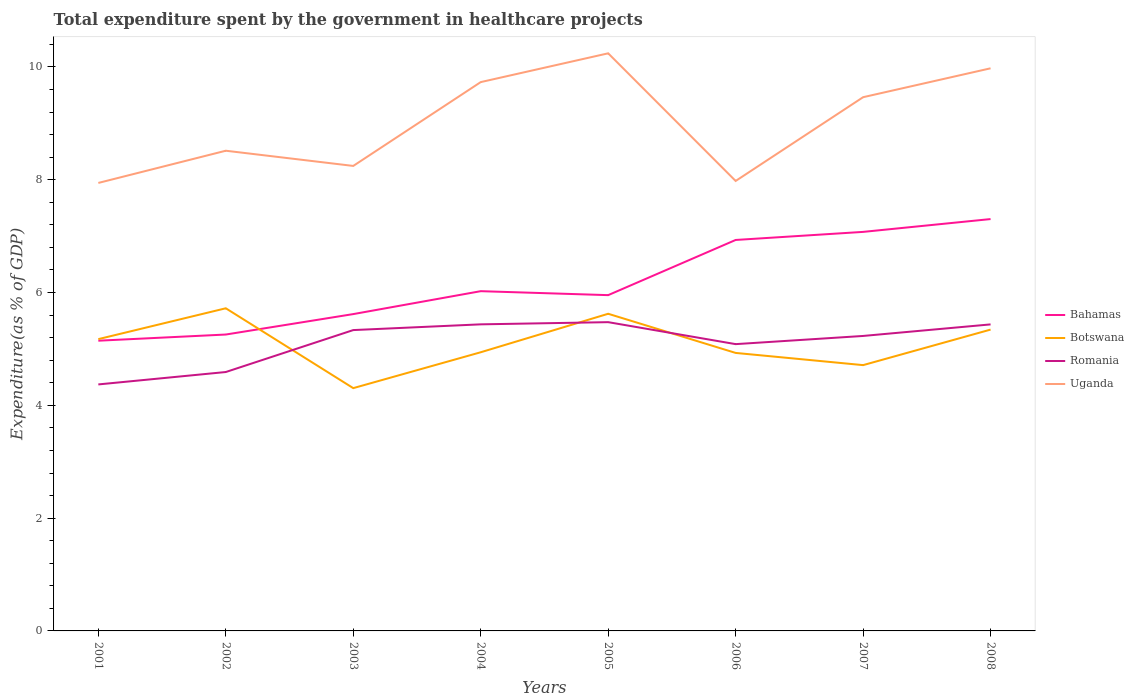Does the line corresponding to Romania intersect with the line corresponding to Botswana?
Provide a short and direct response. Yes. Is the number of lines equal to the number of legend labels?
Keep it short and to the point. Yes. Across all years, what is the maximum total expenditure spent by the government in healthcare projects in Romania?
Offer a very short reply. 4.37. What is the total total expenditure spent by the government in healthcare projects in Botswana in the graph?
Your answer should be very brief. -0.63. What is the difference between the highest and the second highest total expenditure spent by the government in healthcare projects in Uganda?
Make the answer very short. 2.3. What is the difference between two consecutive major ticks on the Y-axis?
Your response must be concise. 2. Are the values on the major ticks of Y-axis written in scientific E-notation?
Make the answer very short. No. Does the graph contain any zero values?
Your answer should be very brief. No. How many legend labels are there?
Ensure brevity in your answer.  4. How are the legend labels stacked?
Offer a terse response. Vertical. What is the title of the graph?
Your answer should be very brief. Total expenditure spent by the government in healthcare projects. Does "Nigeria" appear as one of the legend labels in the graph?
Give a very brief answer. No. What is the label or title of the Y-axis?
Your response must be concise. Expenditure(as % of GDP). What is the Expenditure(as % of GDP) in Bahamas in 2001?
Ensure brevity in your answer.  5.15. What is the Expenditure(as % of GDP) in Botswana in 2001?
Give a very brief answer. 5.17. What is the Expenditure(as % of GDP) of Romania in 2001?
Provide a short and direct response. 4.37. What is the Expenditure(as % of GDP) in Uganda in 2001?
Keep it short and to the point. 7.94. What is the Expenditure(as % of GDP) in Bahamas in 2002?
Your answer should be very brief. 5.26. What is the Expenditure(as % of GDP) in Botswana in 2002?
Make the answer very short. 5.72. What is the Expenditure(as % of GDP) of Romania in 2002?
Provide a succinct answer. 4.59. What is the Expenditure(as % of GDP) in Uganda in 2002?
Your answer should be very brief. 8.51. What is the Expenditure(as % of GDP) in Bahamas in 2003?
Make the answer very short. 5.62. What is the Expenditure(as % of GDP) in Botswana in 2003?
Your answer should be compact. 4.31. What is the Expenditure(as % of GDP) of Romania in 2003?
Provide a succinct answer. 5.33. What is the Expenditure(as % of GDP) of Uganda in 2003?
Provide a succinct answer. 8.25. What is the Expenditure(as % of GDP) in Bahamas in 2004?
Your answer should be compact. 6.02. What is the Expenditure(as % of GDP) of Botswana in 2004?
Keep it short and to the point. 4.94. What is the Expenditure(as % of GDP) in Romania in 2004?
Keep it short and to the point. 5.44. What is the Expenditure(as % of GDP) of Uganda in 2004?
Your answer should be very brief. 9.73. What is the Expenditure(as % of GDP) of Bahamas in 2005?
Keep it short and to the point. 5.95. What is the Expenditure(as % of GDP) of Botswana in 2005?
Your answer should be compact. 5.62. What is the Expenditure(as % of GDP) of Romania in 2005?
Keep it short and to the point. 5.48. What is the Expenditure(as % of GDP) in Uganda in 2005?
Keep it short and to the point. 10.24. What is the Expenditure(as % of GDP) of Bahamas in 2006?
Give a very brief answer. 6.93. What is the Expenditure(as % of GDP) of Botswana in 2006?
Keep it short and to the point. 4.93. What is the Expenditure(as % of GDP) of Romania in 2006?
Ensure brevity in your answer.  5.09. What is the Expenditure(as % of GDP) in Uganda in 2006?
Provide a succinct answer. 7.98. What is the Expenditure(as % of GDP) of Bahamas in 2007?
Make the answer very short. 7.08. What is the Expenditure(as % of GDP) in Botswana in 2007?
Your answer should be compact. 4.71. What is the Expenditure(as % of GDP) of Romania in 2007?
Ensure brevity in your answer.  5.23. What is the Expenditure(as % of GDP) of Uganda in 2007?
Ensure brevity in your answer.  9.46. What is the Expenditure(as % of GDP) in Bahamas in 2008?
Offer a terse response. 7.3. What is the Expenditure(as % of GDP) of Botswana in 2008?
Provide a short and direct response. 5.34. What is the Expenditure(as % of GDP) of Romania in 2008?
Give a very brief answer. 5.44. What is the Expenditure(as % of GDP) of Uganda in 2008?
Provide a succinct answer. 9.98. Across all years, what is the maximum Expenditure(as % of GDP) of Bahamas?
Make the answer very short. 7.3. Across all years, what is the maximum Expenditure(as % of GDP) of Botswana?
Offer a terse response. 5.72. Across all years, what is the maximum Expenditure(as % of GDP) in Romania?
Offer a terse response. 5.48. Across all years, what is the maximum Expenditure(as % of GDP) of Uganda?
Make the answer very short. 10.24. Across all years, what is the minimum Expenditure(as % of GDP) of Bahamas?
Your answer should be compact. 5.15. Across all years, what is the minimum Expenditure(as % of GDP) in Botswana?
Your answer should be very brief. 4.31. Across all years, what is the minimum Expenditure(as % of GDP) of Romania?
Provide a short and direct response. 4.37. Across all years, what is the minimum Expenditure(as % of GDP) of Uganda?
Your answer should be compact. 7.94. What is the total Expenditure(as % of GDP) of Bahamas in the graph?
Your response must be concise. 49.31. What is the total Expenditure(as % of GDP) of Botswana in the graph?
Give a very brief answer. 40.75. What is the total Expenditure(as % of GDP) of Romania in the graph?
Provide a short and direct response. 40.96. What is the total Expenditure(as % of GDP) of Uganda in the graph?
Provide a succinct answer. 72.1. What is the difference between the Expenditure(as % of GDP) of Bahamas in 2001 and that in 2002?
Your answer should be very brief. -0.11. What is the difference between the Expenditure(as % of GDP) of Botswana in 2001 and that in 2002?
Provide a short and direct response. -0.55. What is the difference between the Expenditure(as % of GDP) of Romania in 2001 and that in 2002?
Your answer should be compact. -0.22. What is the difference between the Expenditure(as % of GDP) in Uganda in 2001 and that in 2002?
Offer a very short reply. -0.57. What is the difference between the Expenditure(as % of GDP) of Bahamas in 2001 and that in 2003?
Your answer should be compact. -0.47. What is the difference between the Expenditure(as % of GDP) in Botswana in 2001 and that in 2003?
Offer a very short reply. 0.87. What is the difference between the Expenditure(as % of GDP) in Romania in 2001 and that in 2003?
Give a very brief answer. -0.96. What is the difference between the Expenditure(as % of GDP) of Uganda in 2001 and that in 2003?
Provide a short and direct response. -0.3. What is the difference between the Expenditure(as % of GDP) in Bahamas in 2001 and that in 2004?
Your response must be concise. -0.88. What is the difference between the Expenditure(as % of GDP) in Botswana in 2001 and that in 2004?
Provide a short and direct response. 0.23. What is the difference between the Expenditure(as % of GDP) in Romania in 2001 and that in 2004?
Offer a very short reply. -1.07. What is the difference between the Expenditure(as % of GDP) in Uganda in 2001 and that in 2004?
Provide a succinct answer. -1.79. What is the difference between the Expenditure(as % of GDP) of Bahamas in 2001 and that in 2005?
Your response must be concise. -0.81. What is the difference between the Expenditure(as % of GDP) in Botswana in 2001 and that in 2005?
Provide a short and direct response. -0.45. What is the difference between the Expenditure(as % of GDP) in Romania in 2001 and that in 2005?
Keep it short and to the point. -1.1. What is the difference between the Expenditure(as % of GDP) in Uganda in 2001 and that in 2005?
Give a very brief answer. -2.3. What is the difference between the Expenditure(as % of GDP) in Bahamas in 2001 and that in 2006?
Provide a succinct answer. -1.79. What is the difference between the Expenditure(as % of GDP) of Botswana in 2001 and that in 2006?
Ensure brevity in your answer.  0.24. What is the difference between the Expenditure(as % of GDP) in Romania in 2001 and that in 2006?
Make the answer very short. -0.71. What is the difference between the Expenditure(as % of GDP) of Uganda in 2001 and that in 2006?
Offer a very short reply. -0.04. What is the difference between the Expenditure(as % of GDP) of Bahamas in 2001 and that in 2007?
Your answer should be very brief. -1.93. What is the difference between the Expenditure(as % of GDP) in Botswana in 2001 and that in 2007?
Offer a terse response. 0.46. What is the difference between the Expenditure(as % of GDP) in Romania in 2001 and that in 2007?
Provide a succinct answer. -0.86. What is the difference between the Expenditure(as % of GDP) in Uganda in 2001 and that in 2007?
Ensure brevity in your answer.  -1.52. What is the difference between the Expenditure(as % of GDP) of Bahamas in 2001 and that in 2008?
Offer a terse response. -2.16. What is the difference between the Expenditure(as % of GDP) in Botswana in 2001 and that in 2008?
Provide a short and direct response. -0.17. What is the difference between the Expenditure(as % of GDP) of Romania in 2001 and that in 2008?
Your response must be concise. -1.06. What is the difference between the Expenditure(as % of GDP) of Uganda in 2001 and that in 2008?
Your answer should be very brief. -2.03. What is the difference between the Expenditure(as % of GDP) of Bahamas in 2002 and that in 2003?
Give a very brief answer. -0.36. What is the difference between the Expenditure(as % of GDP) of Botswana in 2002 and that in 2003?
Your answer should be very brief. 1.42. What is the difference between the Expenditure(as % of GDP) of Romania in 2002 and that in 2003?
Keep it short and to the point. -0.74. What is the difference between the Expenditure(as % of GDP) of Uganda in 2002 and that in 2003?
Your answer should be compact. 0.27. What is the difference between the Expenditure(as % of GDP) of Bahamas in 2002 and that in 2004?
Give a very brief answer. -0.77. What is the difference between the Expenditure(as % of GDP) in Botswana in 2002 and that in 2004?
Give a very brief answer. 0.78. What is the difference between the Expenditure(as % of GDP) of Romania in 2002 and that in 2004?
Give a very brief answer. -0.85. What is the difference between the Expenditure(as % of GDP) in Uganda in 2002 and that in 2004?
Your response must be concise. -1.22. What is the difference between the Expenditure(as % of GDP) of Bahamas in 2002 and that in 2005?
Provide a succinct answer. -0.7. What is the difference between the Expenditure(as % of GDP) in Botswana in 2002 and that in 2005?
Provide a succinct answer. 0.1. What is the difference between the Expenditure(as % of GDP) of Romania in 2002 and that in 2005?
Your answer should be compact. -0.88. What is the difference between the Expenditure(as % of GDP) in Uganda in 2002 and that in 2005?
Give a very brief answer. -1.73. What is the difference between the Expenditure(as % of GDP) in Bahamas in 2002 and that in 2006?
Your answer should be compact. -1.68. What is the difference between the Expenditure(as % of GDP) of Botswana in 2002 and that in 2006?
Provide a succinct answer. 0.79. What is the difference between the Expenditure(as % of GDP) in Romania in 2002 and that in 2006?
Your answer should be very brief. -0.49. What is the difference between the Expenditure(as % of GDP) of Uganda in 2002 and that in 2006?
Provide a short and direct response. 0.54. What is the difference between the Expenditure(as % of GDP) in Bahamas in 2002 and that in 2007?
Offer a terse response. -1.82. What is the difference between the Expenditure(as % of GDP) in Botswana in 2002 and that in 2007?
Provide a short and direct response. 1.01. What is the difference between the Expenditure(as % of GDP) of Romania in 2002 and that in 2007?
Ensure brevity in your answer.  -0.64. What is the difference between the Expenditure(as % of GDP) of Uganda in 2002 and that in 2007?
Give a very brief answer. -0.95. What is the difference between the Expenditure(as % of GDP) of Bahamas in 2002 and that in 2008?
Give a very brief answer. -2.05. What is the difference between the Expenditure(as % of GDP) of Botswana in 2002 and that in 2008?
Provide a short and direct response. 0.38. What is the difference between the Expenditure(as % of GDP) of Romania in 2002 and that in 2008?
Offer a terse response. -0.84. What is the difference between the Expenditure(as % of GDP) of Uganda in 2002 and that in 2008?
Ensure brevity in your answer.  -1.46. What is the difference between the Expenditure(as % of GDP) of Bahamas in 2003 and that in 2004?
Your response must be concise. -0.41. What is the difference between the Expenditure(as % of GDP) of Botswana in 2003 and that in 2004?
Keep it short and to the point. -0.64. What is the difference between the Expenditure(as % of GDP) in Romania in 2003 and that in 2004?
Offer a very short reply. -0.1. What is the difference between the Expenditure(as % of GDP) of Uganda in 2003 and that in 2004?
Provide a succinct answer. -1.49. What is the difference between the Expenditure(as % of GDP) in Bahamas in 2003 and that in 2005?
Provide a short and direct response. -0.34. What is the difference between the Expenditure(as % of GDP) of Botswana in 2003 and that in 2005?
Offer a very short reply. -1.32. What is the difference between the Expenditure(as % of GDP) of Romania in 2003 and that in 2005?
Offer a very short reply. -0.14. What is the difference between the Expenditure(as % of GDP) of Uganda in 2003 and that in 2005?
Provide a succinct answer. -2. What is the difference between the Expenditure(as % of GDP) in Bahamas in 2003 and that in 2006?
Ensure brevity in your answer.  -1.31. What is the difference between the Expenditure(as % of GDP) of Botswana in 2003 and that in 2006?
Provide a short and direct response. -0.62. What is the difference between the Expenditure(as % of GDP) of Romania in 2003 and that in 2006?
Offer a very short reply. 0.25. What is the difference between the Expenditure(as % of GDP) in Uganda in 2003 and that in 2006?
Give a very brief answer. 0.27. What is the difference between the Expenditure(as % of GDP) in Bahamas in 2003 and that in 2007?
Your answer should be compact. -1.46. What is the difference between the Expenditure(as % of GDP) of Botswana in 2003 and that in 2007?
Keep it short and to the point. -0.41. What is the difference between the Expenditure(as % of GDP) in Romania in 2003 and that in 2007?
Provide a succinct answer. 0.1. What is the difference between the Expenditure(as % of GDP) in Uganda in 2003 and that in 2007?
Provide a succinct answer. -1.22. What is the difference between the Expenditure(as % of GDP) of Bahamas in 2003 and that in 2008?
Your answer should be compact. -1.69. What is the difference between the Expenditure(as % of GDP) of Botswana in 2003 and that in 2008?
Give a very brief answer. -1.04. What is the difference between the Expenditure(as % of GDP) of Romania in 2003 and that in 2008?
Your answer should be very brief. -0.1. What is the difference between the Expenditure(as % of GDP) of Uganda in 2003 and that in 2008?
Give a very brief answer. -1.73. What is the difference between the Expenditure(as % of GDP) of Bahamas in 2004 and that in 2005?
Provide a succinct answer. 0.07. What is the difference between the Expenditure(as % of GDP) in Botswana in 2004 and that in 2005?
Your answer should be compact. -0.68. What is the difference between the Expenditure(as % of GDP) of Romania in 2004 and that in 2005?
Offer a terse response. -0.04. What is the difference between the Expenditure(as % of GDP) in Uganda in 2004 and that in 2005?
Your answer should be compact. -0.51. What is the difference between the Expenditure(as % of GDP) of Bahamas in 2004 and that in 2006?
Offer a terse response. -0.91. What is the difference between the Expenditure(as % of GDP) in Botswana in 2004 and that in 2006?
Offer a terse response. 0.01. What is the difference between the Expenditure(as % of GDP) in Romania in 2004 and that in 2006?
Make the answer very short. 0.35. What is the difference between the Expenditure(as % of GDP) of Uganda in 2004 and that in 2006?
Ensure brevity in your answer.  1.75. What is the difference between the Expenditure(as % of GDP) of Bahamas in 2004 and that in 2007?
Your response must be concise. -1.05. What is the difference between the Expenditure(as % of GDP) in Botswana in 2004 and that in 2007?
Give a very brief answer. 0.23. What is the difference between the Expenditure(as % of GDP) of Romania in 2004 and that in 2007?
Give a very brief answer. 0.21. What is the difference between the Expenditure(as % of GDP) of Uganda in 2004 and that in 2007?
Offer a terse response. 0.27. What is the difference between the Expenditure(as % of GDP) of Bahamas in 2004 and that in 2008?
Give a very brief answer. -1.28. What is the difference between the Expenditure(as % of GDP) of Botswana in 2004 and that in 2008?
Provide a short and direct response. -0.4. What is the difference between the Expenditure(as % of GDP) of Uganda in 2004 and that in 2008?
Your answer should be compact. -0.24. What is the difference between the Expenditure(as % of GDP) of Bahamas in 2005 and that in 2006?
Your response must be concise. -0.98. What is the difference between the Expenditure(as % of GDP) of Botswana in 2005 and that in 2006?
Keep it short and to the point. 0.69. What is the difference between the Expenditure(as % of GDP) in Romania in 2005 and that in 2006?
Ensure brevity in your answer.  0.39. What is the difference between the Expenditure(as % of GDP) of Uganda in 2005 and that in 2006?
Make the answer very short. 2.26. What is the difference between the Expenditure(as % of GDP) in Bahamas in 2005 and that in 2007?
Your response must be concise. -1.12. What is the difference between the Expenditure(as % of GDP) of Botswana in 2005 and that in 2007?
Make the answer very short. 0.91. What is the difference between the Expenditure(as % of GDP) of Romania in 2005 and that in 2007?
Your answer should be compact. 0.24. What is the difference between the Expenditure(as % of GDP) of Uganda in 2005 and that in 2007?
Ensure brevity in your answer.  0.78. What is the difference between the Expenditure(as % of GDP) in Bahamas in 2005 and that in 2008?
Provide a succinct answer. -1.35. What is the difference between the Expenditure(as % of GDP) in Botswana in 2005 and that in 2008?
Provide a succinct answer. 0.28. What is the difference between the Expenditure(as % of GDP) in Romania in 2005 and that in 2008?
Give a very brief answer. 0.04. What is the difference between the Expenditure(as % of GDP) of Uganda in 2005 and that in 2008?
Your response must be concise. 0.27. What is the difference between the Expenditure(as % of GDP) of Bahamas in 2006 and that in 2007?
Offer a very short reply. -0.14. What is the difference between the Expenditure(as % of GDP) in Botswana in 2006 and that in 2007?
Your answer should be compact. 0.22. What is the difference between the Expenditure(as % of GDP) of Romania in 2006 and that in 2007?
Keep it short and to the point. -0.15. What is the difference between the Expenditure(as % of GDP) in Uganda in 2006 and that in 2007?
Your answer should be very brief. -1.49. What is the difference between the Expenditure(as % of GDP) of Bahamas in 2006 and that in 2008?
Provide a short and direct response. -0.37. What is the difference between the Expenditure(as % of GDP) in Botswana in 2006 and that in 2008?
Your answer should be compact. -0.41. What is the difference between the Expenditure(as % of GDP) of Romania in 2006 and that in 2008?
Provide a succinct answer. -0.35. What is the difference between the Expenditure(as % of GDP) in Uganda in 2006 and that in 2008?
Keep it short and to the point. -2. What is the difference between the Expenditure(as % of GDP) in Bahamas in 2007 and that in 2008?
Keep it short and to the point. -0.23. What is the difference between the Expenditure(as % of GDP) of Botswana in 2007 and that in 2008?
Ensure brevity in your answer.  -0.63. What is the difference between the Expenditure(as % of GDP) of Romania in 2007 and that in 2008?
Keep it short and to the point. -0.2. What is the difference between the Expenditure(as % of GDP) in Uganda in 2007 and that in 2008?
Offer a very short reply. -0.51. What is the difference between the Expenditure(as % of GDP) of Bahamas in 2001 and the Expenditure(as % of GDP) of Botswana in 2002?
Your response must be concise. -0.57. What is the difference between the Expenditure(as % of GDP) in Bahamas in 2001 and the Expenditure(as % of GDP) in Romania in 2002?
Your answer should be very brief. 0.56. What is the difference between the Expenditure(as % of GDP) in Bahamas in 2001 and the Expenditure(as % of GDP) in Uganda in 2002?
Keep it short and to the point. -3.37. What is the difference between the Expenditure(as % of GDP) of Botswana in 2001 and the Expenditure(as % of GDP) of Romania in 2002?
Provide a short and direct response. 0.58. What is the difference between the Expenditure(as % of GDP) of Botswana in 2001 and the Expenditure(as % of GDP) of Uganda in 2002?
Offer a terse response. -3.34. What is the difference between the Expenditure(as % of GDP) of Romania in 2001 and the Expenditure(as % of GDP) of Uganda in 2002?
Provide a short and direct response. -4.14. What is the difference between the Expenditure(as % of GDP) of Bahamas in 2001 and the Expenditure(as % of GDP) of Botswana in 2003?
Keep it short and to the point. 0.84. What is the difference between the Expenditure(as % of GDP) of Bahamas in 2001 and the Expenditure(as % of GDP) of Romania in 2003?
Provide a short and direct response. -0.19. What is the difference between the Expenditure(as % of GDP) in Bahamas in 2001 and the Expenditure(as % of GDP) in Uganda in 2003?
Keep it short and to the point. -3.1. What is the difference between the Expenditure(as % of GDP) in Botswana in 2001 and the Expenditure(as % of GDP) in Romania in 2003?
Ensure brevity in your answer.  -0.16. What is the difference between the Expenditure(as % of GDP) in Botswana in 2001 and the Expenditure(as % of GDP) in Uganda in 2003?
Your answer should be very brief. -3.07. What is the difference between the Expenditure(as % of GDP) in Romania in 2001 and the Expenditure(as % of GDP) in Uganda in 2003?
Provide a short and direct response. -3.87. What is the difference between the Expenditure(as % of GDP) in Bahamas in 2001 and the Expenditure(as % of GDP) in Botswana in 2004?
Offer a very short reply. 0.2. What is the difference between the Expenditure(as % of GDP) in Bahamas in 2001 and the Expenditure(as % of GDP) in Romania in 2004?
Ensure brevity in your answer.  -0.29. What is the difference between the Expenditure(as % of GDP) in Bahamas in 2001 and the Expenditure(as % of GDP) in Uganda in 2004?
Offer a very short reply. -4.59. What is the difference between the Expenditure(as % of GDP) in Botswana in 2001 and the Expenditure(as % of GDP) in Romania in 2004?
Offer a very short reply. -0.26. What is the difference between the Expenditure(as % of GDP) of Botswana in 2001 and the Expenditure(as % of GDP) of Uganda in 2004?
Offer a terse response. -4.56. What is the difference between the Expenditure(as % of GDP) in Romania in 2001 and the Expenditure(as % of GDP) in Uganda in 2004?
Provide a succinct answer. -5.36. What is the difference between the Expenditure(as % of GDP) in Bahamas in 2001 and the Expenditure(as % of GDP) in Botswana in 2005?
Your answer should be very brief. -0.48. What is the difference between the Expenditure(as % of GDP) in Bahamas in 2001 and the Expenditure(as % of GDP) in Romania in 2005?
Your response must be concise. -0.33. What is the difference between the Expenditure(as % of GDP) of Bahamas in 2001 and the Expenditure(as % of GDP) of Uganda in 2005?
Offer a terse response. -5.1. What is the difference between the Expenditure(as % of GDP) of Botswana in 2001 and the Expenditure(as % of GDP) of Romania in 2005?
Give a very brief answer. -0.3. What is the difference between the Expenditure(as % of GDP) in Botswana in 2001 and the Expenditure(as % of GDP) in Uganda in 2005?
Ensure brevity in your answer.  -5.07. What is the difference between the Expenditure(as % of GDP) in Romania in 2001 and the Expenditure(as % of GDP) in Uganda in 2005?
Offer a terse response. -5.87. What is the difference between the Expenditure(as % of GDP) in Bahamas in 2001 and the Expenditure(as % of GDP) in Botswana in 2006?
Offer a terse response. 0.22. What is the difference between the Expenditure(as % of GDP) in Bahamas in 2001 and the Expenditure(as % of GDP) in Romania in 2006?
Offer a terse response. 0.06. What is the difference between the Expenditure(as % of GDP) in Bahamas in 2001 and the Expenditure(as % of GDP) in Uganda in 2006?
Provide a short and direct response. -2.83. What is the difference between the Expenditure(as % of GDP) in Botswana in 2001 and the Expenditure(as % of GDP) in Romania in 2006?
Your answer should be very brief. 0.09. What is the difference between the Expenditure(as % of GDP) in Botswana in 2001 and the Expenditure(as % of GDP) in Uganda in 2006?
Offer a very short reply. -2.8. What is the difference between the Expenditure(as % of GDP) in Romania in 2001 and the Expenditure(as % of GDP) in Uganda in 2006?
Ensure brevity in your answer.  -3.61. What is the difference between the Expenditure(as % of GDP) of Bahamas in 2001 and the Expenditure(as % of GDP) of Botswana in 2007?
Ensure brevity in your answer.  0.43. What is the difference between the Expenditure(as % of GDP) of Bahamas in 2001 and the Expenditure(as % of GDP) of Romania in 2007?
Give a very brief answer. -0.08. What is the difference between the Expenditure(as % of GDP) in Bahamas in 2001 and the Expenditure(as % of GDP) in Uganda in 2007?
Your response must be concise. -4.32. What is the difference between the Expenditure(as % of GDP) in Botswana in 2001 and the Expenditure(as % of GDP) in Romania in 2007?
Offer a very short reply. -0.06. What is the difference between the Expenditure(as % of GDP) in Botswana in 2001 and the Expenditure(as % of GDP) in Uganda in 2007?
Ensure brevity in your answer.  -4.29. What is the difference between the Expenditure(as % of GDP) in Romania in 2001 and the Expenditure(as % of GDP) in Uganda in 2007?
Keep it short and to the point. -5.09. What is the difference between the Expenditure(as % of GDP) of Bahamas in 2001 and the Expenditure(as % of GDP) of Botswana in 2008?
Your response must be concise. -0.2. What is the difference between the Expenditure(as % of GDP) in Bahamas in 2001 and the Expenditure(as % of GDP) in Romania in 2008?
Offer a very short reply. -0.29. What is the difference between the Expenditure(as % of GDP) of Bahamas in 2001 and the Expenditure(as % of GDP) of Uganda in 2008?
Provide a succinct answer. -4.83. What is the difference between the Expenditure(as % of GDP) of Botswana in 2001 and the Expenditure(as % of GDP) of Romania in 2008?
Offer a terse response. -0.26. What is the difference between the Expenditure(as % of GDP) of Botswana in 2001 and the Expenditure(as % of GDP) of Uganda in 2008?
Provide a succinct answer. -4.8. What is the difference between the Expenditure(as % of GDP) in Romania in 2001 and the Expenditure(as % of GDP) in Uganda in 2008?
Your answer should be very brief. -5.61. What is the difference between the Expenditure(as % of GDP) in Bahamas in 2002 and the Expenditure(as % of GDP) in Botswana in 2003?
Offer a terse response. 0.95. What is the difference between the Expenditure(as % of GDP) of Bahamas in 2002 and the Expenditure(as % of GDP) of Romania in 2003?
Keep it short and to the point. -0.08. What is the difference between the Expenditure(as % of GDP) of Bahamas in 2002 and the Expenditure(as % of GDP) of Uganda in 2003?
Your answer should be compact. -2.99. What is the difference between the Expenditure(as % of GDP) in Botswana in 2002 and the Expenditure(as % of GDP) in Romania in 2003?
Provide a short and direct response. 0.39. What is the difference between the Expenditure(as % of GDP) of Botswana in 2002 and the Expenditure(as % of GDP) of Uganda in 2003?
Keep it short and to the point. -2.52. What is the difference between the Expenditure(as % of GDP) in Romania in 2002 and the Expenditure(as % of GDP) in Uganda in 2003?
Your response must be concise. -3.65. What is the difference between the Expenditure(as % of GDP) in Bahamas in 2002 and the Expenditure(as % of GDP) in Botswana in 2004?
Offer a terse response. 0.31. What is the difference between the Expenditure(as % of GDP) of Bahamas in 2002 and the Expenditure(as % of GDP) of Romania in 2004?
Your answer should be very brief. -0.18. What is the difference between the Expenditure(as % of GDP) of Bahamas in 2002 and the Expenditure(as % of GDP) of Uganda in 2004?
Your response must be concise. -4.48. What is the difference between the Expenditure(as % of GDP) in Botswana in 2002 and the Expenditure(as % of GDP) in Romania in 2004?
Make the answer very short. 0.28. What is the difference between the Expenditure(as % of GDP) of Botswana in 2002 and the Expenditure(as % of GDP) of Uganda in 2004?
Your answer should be very brief. -4.01. What is the difference between the Expenditure(as % of GDP) of Romania in 2002 and the Expenditure(as % of GDP) of Uganda in 2004?
Ensure brevity in your answer.  -5.14. What is the difference between the Expenditure(as % of GDP) of Bahamas in 2002 and the Expenditure(as % of GDP) of Botswana in 2005?
Your answer should be compact. -0.37. What is the difference between the Expenditure(as % of GDP) of Bahamas in 2002 and the Expenditure(as % of GDP) of Romania in 2005?
Give a very brief answer. -0.22. What is the difference between the Expenditure(as % of GDP) of Bahamas in 2002 and the Expenditure(as % of GDP) of Uganda in 2005?
Offer a very short reply. -4.99. What is the difference between the Expenditure(as % of GDP) of Botswana in 2002 and the Expenditure(as % of GDP) of Romania in 2005?
Ensure brevity in your answer.  0.25. What is the difference between the Expenditure(as % of GDP) in Botswana in 2002 and the Expenditure(as % of GDP) in Uganda in 2005?
Make the answer very short. -4.52. What is the difference between the Expenditure(as % of GDP) of Romania in 2002 and the Expenditure(as % of GDP) of Uganda in 2005?
Ensure brevity in your answer.  -5.65. What is the difference between the Expenditure(as % of GDP) in Bahamas in 2002 and the Expenditure(as % of GDP) in Botswana in 2006?
Give a very brief answer. 0.33. What is the difference between the Expenditure(as % of GDP) in Bahamas in 2002 and the Expenditure(as % of GDP) in Romania in 2006?
Offer a very short reply. 0.17. What is the difference between the Expenditure(as % of GDP) in Bahamas in 2002 and the Expenditure(as % of GDP) in Uganda in 2006?
Your answer should be compact. -2.72. What is the difference between the Expenditure(as % of GDP) in Botswana in 2002 and the Expenditure(as % of GDP) in Romania in 2006?
Provide a short and direct response. 0.64. What is the difference between the Expenditure(as % of GDP) of Botswana in 2002 and the Expenditure(as % of GDP) of Uganda in 2006?
Keep it short and to the point. -2.26. What is the difference between the Expenditure(as % of GDP) of Romania in 2002 and the Expenditure(as % of GDP) of Uganda in 2006?
Your response must be concise. -3.39. What is the difference between the Expenditure(as % of GDP) of Bahamas in 2002 and the Expenditure(as % of GDP) of Botswana in 2007?
Give a very brief answer. 0.54. What is the difference between the Expenditure(as % of GDP) of Bahamas in 2002 and the Expenditure(as % of GDP) of Romania in 2007?
Ensure brevity in your answer.  0.03. What is the difference between the Expenditure(as % of GDP) of Bahamas in 2002 and the Expenditure(as % of GDP) of Uganda in 2007?
Keep it short and to the point. -4.21. What is the difference between the Expenditure(as % of GDP) in Botswana in 2002 and the Expenditure(as % of GDP) in Romania in 2007?
Your answer should be compact. 0.49. What is the difference between the Expenditure(as % of GDP) of Botswana in 2002 and the Expenditure(as % of GDP) of Uganda in 2007?
Provide a short and direct response. -3.74. What is the difference between the Expenditure(as % of GDP) of Romania in 2002 and the Expenditure(as % of GDP) of Uganda in 2007?
Make the answer very short. -4.87. What is the difference between the Expenditure(as % of GDP) of Bahamas in 2002 and the Expenditure(as % of GDP) of Botswana in 2008?
Make the answer very short. -0.09. What is the difference between the Expenditure(as % of GDP) of Bahamas in 2002 and the Expenditure(as % of GDP) of Romania in 2008?
Your answer should be compact. -0.18. What is the difference between the Expenditure(as % of GDP) in Bahamas in 2002 and the Expenditure(as % of GDP) in Uganda in 2008?
Your response must be concise. -4.72. What is the difference between the Expenditure(as % of GDP) in Botswana in 2002 and the Expenditure(as % of GDP) in Romania in 2008?
Keep it short and to the point. 0.29. What is the difference between the Expenditure(as % of GDP) in Botswana in 2002 and the Expenditure(as % of GDP) in Uganda in 2008?
Keep it short and to the point. -4.26. What is the difference between the Expenditure(as % of GDP) of Romania in 2002 and the Expenditure(as % of GDP) of Uganda in 2008?
Provide a short and direct response. -5.39. What is the difference between the Expenditure(as % of GDP) in Bahamas in 2003 and the Expenditure(as % of GDP) in Botswana in 2004?
Your response must be concise. 0.68. What is the difference between the Expenditure(as % of GDP) in Bahamas in 2003 and the Expenditure(as % of GDP) in Romania in 2004?
Give a very brief answer. 0.18. What is the difference between the Expenditure(as % of GDP) in Bahamas in 2003 and the Expenditure(as % of GDP) in Uganda in 2004?
Make the answer very short. -4.11. What is the difference between the Expenditure(as % of GDP) of Botswana in 2003 and the Expenditure(as % of GDP) of Romania in 2004?
Ensure brevity in your answer.  -1.13. What is the difference between the Expenditure(as % of GDP) of Botswana in 2003 and the Expenditure(as % of GDP) of Uganda in 2004?
Give a very brief answer. -5.43. What is the difference between the Expenditure(as % of GDP) of Romania in 2003 and the Expenditure(as % of GDP) of Uganda in 2004?
Keep it short and to the point. -4.4. What is the difference between the Expenditure(as % of GDP) of Bahamas in 2003 and the Expenditure(as % of GDP) of Botswana in 2005?
Provide a succinct answer. -0.01. What is the difference between the Expenditure(as % of GDP) in Bahamas in 2003 and the Expenditure(as % of GDP) in Romania in 2005?
Make the answer very short. 0.14. What is the difference between the Expenditure(as % of GDP) of Bahamas in 2003 and the Expenditure(as % of GDP) of Uganda in 2005?
Your answer should be compact. -4.62. What is the difference between the Expenditure(as % of GDP) in Botswana in 2003 and the Expenditure(as % of GDP) in Romania in 2005?
Provide a short and direct response. -1.17. What is the difference between the Expenditure(as % of GDP) of Botswana in 2003 and the Expenditure(as % of GDP) of Uganda in 2005?
Keep it short and to the point. -5.94. What is the difference between the Expenditure(as % of GDP) in Romania in 2003 and the Expenditure(as % of GDP) in Uganda in 2005?
Make the answer very short. -4.91. What is the difference between the Expenditure(as % of GDP) of Bahamas in 2003 and the Expenditure(as % of GDP) of Botswana in 2006?
Offer a very short reply. 0.69. What is the difference between the Expenditure(as % of GDP) of Bahamas in 2003 and the Expenditure(as % of GDP) of Romania in 2006?
Ensure brevity in your answer.  0.53. What is the difference between the Expenditure(as % of GDP) in Bahamas in 2003 and the Expenditure(as % of GDP) in Uganda in 2006?
Your response must be concise. -2.36. What is the difference between the Expenditure(as % of GDP) of Botswana in 2003 and the Expenditure(as % of GDP) of Romania in 2006?
Your answer should be very brief. -0.78. What is the difference between the Expenditure(as % of GDP) of Botswana in 2003 and the Expenditure(as % of GDP) of Uganda in 2006?
Provide a short and direct response. -3.67. What is the difference between the Expenditure(as % of GDP) in Romania in 2003 and the Expenditure(as % of GDP) in Uganda in 2006?
Your answer should be compact. -2.64. What is the difference between the Expenditure(as % of GDP) of Bahamas in 2003 and the Expenditure(as % of GDP) of Botswana in 2007?
Offer a very short reply. 0.9. What is the difference between the Expenditure(as % of GDP) in Bahamas in 2003 and the Expenditure(as % of GDP) in Romania in 2007?
Offer a very short reply. 0.39. What is the difference between the Expenditure(as % of GDP) of Bahamas in 2003 and the Expenditure(as % of GDP) of Uganda in 2007?
Ensure brevity in your answer.  -3.85. What is the difference between the Expenditure(as % of GDP) of Botswana in 2003 and the Expenditure(as % of GDP) of Romania in 2007?
Your answer should be compact. -0.93. What is the difference between the Expenditure(as % of GDP) in Botswana in 2003 and the Expenditure(as % of GDP) in Uganda in 2007?
Make the answer very short. -5.16. What is the difference between the Expenditure(as % of GDP) in Romania in 2003 and the Expenditure(as % of GDP) in Uganda in 2007?
Offer a terse response. -4.13. What is the difference between the Expenditure(as % of GDP) in Bahamas in 2003 and the Expenditure(as % of GDP) in Botswana in 2008?
Provide a short and direct response. 0.27. What is the difference between the Expenditure(as % of GDP) of Bahamas in 2003 and the Expenditure(as % of GDP) of Romania in 2008?
Your answer should be compact. 0.18. What is the difference between the Expenditure(as % of GDP) of Bahamas in 2003 and the Expenditure(as % of GDP) of Uganda in 2008?
Provide a short and direct response. -4.36. What is the difference between the Expenditure(as % of GDP) in Botswana in 2003 and the Expenditure(as % of GDP) in Romania in 2008?
Your response must be concise. -1.13. What is the difference between the Expenditure(as % of GDP) in Botswana in 2003 and the Expenditure(as % of GDP) in Uganda in 2008?
Give a very brief answer. -5.67. What is the difference between the Expenditure(as % of GDP) in Romania in 2003 and the Expenditure(as % of GDP) in Uganda in 2008?
Give a very brief answer. -4.64. What is the difference between the Expenditure(as % of GDP) of Bahamas in 2004 and the Expenditure(as % of GDP) of Botswana in 2005?
Offer a very short reply. 0.4. What is the difference between the Expenditure(as % of GDP) of Bahamas in 2004 and the Expenditure(as % of GDP) of Romania in 2005?
Make the answer very short. 0.55. What is the difference between the Expenditure(as % of GDP) in Bahamas in 2004 and the Expenditure(as % of GDP) in Uganda in 2005?
Provide a short and direct response. -4.22. What is the difference between the Expenditure(as % of GDP) of Botswana in 2004 and the Expenditure(as % of GDP) of Romania in 2005?
Provide a short and direct response. -0.53. What is the difference between the Expenditure(as % of GDP) in Botswana in 2004 and the Expenditure(as % of GDP) in Uganda in 2005?
Ensure brevity in your answer.  -5.3. What is the difference between the Expenditure(as % of GDP) in Romania in 2004 and the Expenditure(as % of GDP) in Uganda in 2005?
Give a very brief answer. -4.81. What is the difference between the Expenditure(as % of GDP) of Bahamas in 2004 and the Expenditure(as % of GDP) of Botswana in 2006?
Provide a succinct answer. 1.09. What is the difference between the Expenditure(as % of GDP) of Bahamas in 2004 and the Expenditure(as % of GDP) of Romania in 2006?
Provide a succinct answer. 0.94. What is the difference between the Expenditure(as % of GDP) of Bahamas in 2004 and the Expenditure(as % of GDP) of Uganda in 2006?
Give a very brief answer. -1.95. What is the difference between the Expenditure(as % of GDP) of Botswana in 2004 and the Expenditure(as % of GDP) of Romania in 2006?
Your response must be concise. -0.14. What is the difference between the Expenditure(as % of GDP) of Botswana in 2004 and the Expenditure(as % of GDP) of Uganda in 2006?
Make the answer very short. -3.04. What is the difference between the Expenditure(as % of GDP) in Romania in 2004 and the Expenditure(as % of GDP) in Uganda in 2006?
Your answer should be very brief. -2.54. What is the difference between the Expenditure(as % of GDP) of Bahamas in 2004 and the Expenditure(as % of GDP) of Botswana in 2007?
Provide a succinct answer. 1.31. What is the difference between the Expenditure(as % of GDP) of Bahamas in 2004 and the Expenditure(as % of GDP) of Romania in 2007?
Ensure brevity in your answer.  0.79. What is the difference between the Expenditure(as % of GDP) of Bahamas in 2004 and the Expenditure(as % of GDP) of Uganda in 2007?
Make the answer very short. -3.44. What is the difference between the Expenditure(as % of GDP) of Botswana in 2004 and the Expenditure(as % of GDP) of Romania in 2007?
Your response must be concise. -0.29. What is the difference between the Expenditure(as % of GDP) of Botswana in 2004 and the Expenditure(as % of GDP) of Uganda in 2007?
Give a very brief answer. -4.52. What is the difference between the Expenditure(as % of GDP) in Romania in 2004 and the Expenditure(as % of GDP) in Uganda in 2007?
Offer a terse response. -4.03. What is the difference between the Expenditure(as % of GDP) of Bahamas in 2004 and the Expenditure(as % of GDP) of Botswana in 2008?
Ensure brevity in your answer.  0.68. What is the difference between the Expenditure(as % of GDP) in Bahamas in 2004 and the Expenditure(as % of GDP) in Romania in 2008?
Provide a short and direct response. 0.59. What is the difference between the Expenditure(as % of GDP) of Bahamas in 2004 and the Expenditure(as % of GDP) of Uganda in 2008?
Offer a very short reply. -3.95. What is the difference between the Expenditure(as % of GDP) of Botswana in 2004 and the Expenditure(as % of GDP) of Romania in 2008?
Your response must be concise. -0.49. What is the difference between the Expenditure(as % of GDP) of Botswana in 2004 and the Expenditure(as % of GDP) of Uganda in 2008?
Give a very brief answer. -5.04. What is the difference between the Expenditure(as % of GDP) of Romania in 2004 and the Expenditure(as % of GDP) of Uganda in 2008?
Your answer should be compact. -4.54. What is the difference between the Expenditure(as % of GDP) in Bahamas in 2005 and the Expenditure(as % of GDP) in Botswana in 2006?
Keep it short and to the point. 1.02. What is the difference between the Expenditure(as % of GDP) of Bahamas in 2005 and the Expenditure(as % of GDP) of Romania in 2006?
Offer a terse response. 0.87. What is the difference between the Expenditure(as % of GDP) in Bahamas in 2005 and the Expenditure(as % of GDP) in Uganda in 2006?
Your answer should be very brief. -2.02. What is the difference between the Expenditure(as % of GDP) of Botswana in 2005 and the Expenditure(as % of GDP) of Romania in 2006?
Your response must be concise. 0.54. What is the difference between the Expenditure(as % of GDP) in Botswana in 2005 and the Expenditure(as % of GDP) in Uganda in 2006?
Provide a short and direct response. -2.36. What is the difference between the Expenditure(as % of GDP) in Romania in 2005 and the Expenditure(as % of GDP) in Uganda in 2006?
Offer a very short reply. -2.5. What is the difference between the Expenditure(as % of GDP) in Bahamas in 2005 and the Expenditure(as % of GDP) in Botswana in 2007?
Keep it short and to the point. 1.24. What is the difference between the Expenditure(as % of GDP) of Bahamas in 2005 and the Expenditure(as % of GDP) of Romania in 2007?
Keep it short and to the point. 0.72. What is the difference between the Expenditure(as % of GDP) in Bahamas in 2005 and the Expenditure(as % of GDP) in Uganda in 2007?
Offer a very short reply. -3.51. What is the difference between the Expenditure(as % of GDP) of Botswana in 2005 and the Expenditure(as % of GDP) of Romania in 2007?
Give a very brief answer. 0.39. What is the difference between the Expenditure(as % of GDP) of Botswana in 2005 and the Expenditure(as % of GDP) of Uganda in 2007?
Offer a very short reply. -3.84. What is the difference between the Expenditure(as % of GDP) in Romania in 2005 and the Expenditure(as % of GDP) in Uganda in 2007?
Make the answer very short. -3.99. What is the difference between the Expenditure(as % of GDP) of Bahamas in 2005 and the Expenditure(as % of GDP) of Botswana in 2008?
Offer a terse response. 0.61. What is the difference between the Expenditure(as % of GDP) of Bahamas in 2005 and the Expenditure(as % of GDP) of Romania in 2008?
Make the answer very short. 0.52. What is the difference between the Expenditure(as % of GDP) in Bahamas in 2005 and the Expenditure(as % of GDP) in Uganda in 2008?
Keep it short and to the point. -4.02. What is the difference between the Expenditure(as % of GDP) of Botswana in 2005 and the Expenditure(as % of GDP) of Romania in 2008?
Offer a very short reply. 0.19. What is the difference between the Expenditure(as % of GDP) in Botswana in 2005 and the Expenditure(as % of GDP) in Uganda in 2008?
Ensure brevity in your answer.  -4.35. What is the difference between the Expenditure(as % of GDP) in Romania in 2005 and the Expenditure(as % of GDP) in Uganda in 2008?
Provide a succinct answer. -4.5. What is the difference between the Expenditure(as % of GDP) of Bahamas in 2006 and the Expenditure(as % of GDP) of Botswana in 2007?
Keep it short and to the point. 2.22. What is the difference between the Expenditure(as % of GDP) in Bahamas in 2006 and the Expenditure(as % of GDP) in Romania in 2007?
Give a very brief answer. 1.7. What is the difference between the Expenditure(as % of GDP) of Bahamas in 2006 and the Expenditure(as % of GDP) of Uganda in 2007?
Provide a short and direct response. -2.53. What is the difference between the Expenditure(as % of GDP) of Botswana in 2006 and the Expenditure(as % of GDP) of Romania in 2007?
Your answer should be very brief. -0.3. What is the difference between the Expenditure(as % of GDP) in Botswana in 2006 and the Expenditure(as % of GDP) in Uganda in 2007?
Ensure brevity in your answer.  -4.53. What is the difference between the Expenditure(as % of GDP) of Romania in 2006 and the Expenditure(as % of GDP) of Uganda in 2007?
Keep it short and to the point. -4.38. What is the difference between the Expenditure(as % of GDP) in Bahamas in 2006 and the Expenditure(as % of GDP) in Botswana in 2008?
Your response must be concise. 1.59. What is the difference between the Expenditure(as % of GDP) of Bahamas in 2006 and the Expenditure(as % of GDP) of Romania in 2008?
Your response must be concise. 1.5. What is the difference between the Expenditure(as % of GDP) in Bahamas in 2006 and the Expenditure(as % of GDP) in Uganda in 2008?
Your answer should be compact. -3.04. What is the difference between the Expenditure(as % of GDP) of Botswana in 2006 and the Expenditure(as % of GDP) of Romania in 2008?
Your response must be concise. -0.51. What is the difference between the Expenditure(as % of GDP) of Botswana in 2006 and the Expenditure(as % of GDP) of Uganda in 2008?
Your answer should be very brief. -5.05. What is the difference between the Expenditure(as % of GDP) of Romania in 2006 and the Expenditure(as % of GDP) of Uganda in 2008?
Provide a short and direct response. -4.89. What is the difference between the Expenditure(as % of GDP) of Bahamas in 2007 and the Expenditure(as % of GDP) of Botswana in 2008?
Offer a terse response. 1.73. What is the difference between the Expenditure(as % of GDP) in Bahamas in 2007 and the Expenditure(as % of GDP) in Romania in 2008?
Keep it short and to the point. 1.64. What is the difference between the Expenditure(as % of GDP) of Bahamas in 2007 and the Expenditure(as % of GDP) of Uganda in 2008?
Give a very brief answer. -2.9. What is the difference between the Expenditure(as % of GDP) in Botswana in 2007 and the Expenditure(as % of GDP) in Romania in 2008?
Provide a succinct answer. -0.72. What is the difference between the Expenditure(as % of GDP) in Botswana in 2007 and the Expenditure(as % of GDP) in Uganda in 2008?
Make the answer very short. -5.26. What is the difference between the Expenditure(as % of GDP) in Romania in 2007 and the Expenditure(as % of GDP) in Uganda in 2008?
Give a very brief answer. -4.75. What is the average Expenditure(as % of GDP) in Bahamas per year?
Provide a short and direct response. 6.16. What is the average Expenditure(as % of GDP) in Botswana per year?
Ensure brevity in your answer.  5.09. What is the average Expenditure(as % of GDP) in Romania per year?
Give a very brief answer. 5.12. What is the average Expenditure(as % of GDP) of Uganda per year?
Offer a terse response. 9.01. In the year 2001, what is the difference between the Expenditure(as % of GDP) of Bahamas and Expenditure(as % of GDP) of Botswana?
Offer a very short reply. -0.03. In the year 2001, what is the difference between the Expenditure(as % of GDP) of Bahamas and Expenditure(as % of GDP) of Romania?
Ensure brevity in your answer.  0.78. In the year 2001, what is the difference between the Expenditure(as % of GDP) in Bahamas and Expenditure(as % of GDP) in Uganda?
Your answer should be very brief. -2.8. In the year 2001, what is the difference between the Expenditure(as % of GDP) in Botswana and Expenditure(as % of GDP) in Romania?
Offer a very short reply. 0.8. In the year 2001, what is the difference between the Expenditure(as % of GDP) of Botswana and Expenditure(as % of GDP) of Uganda?
Your answer should be compact. -2.77. In the year 2001, what is the difference between the Expenditure(as % of GDP) in Romania and Expenditure(as % of GDP) in Uganda?
Keep it short and to the point. -3.57. In the year 2002, what is the difference between the Expenditure(as % of GDP) of Bahamas and Expenditure(as % of GDP) of Botswana?
Offer a very short reply. -0.47. In the year 2002, what is the difference between the Expenditure(as % of GDP) of Bahamas and Expenditure(as % of GDP) of Romania?
Your answer should be very brief. 0.66. In the year 2002, what is the difference between the Expenditure(as % of GDP) of Bahamas and Expenditure(as % of GDP) of Uganda?
Your answer should be compact. -3.26. In the year 2002, what is the difference between the Expenditure(as % of GDP) in Botswana and Expenditure(as % of GDP) in Romania?
Give a very brief answer. 1.13. In the year 2002, what is the difference between the Expenditure(as % of GDP) of Botswana and Expenditure(as % of GDP) of Uganda?
Give a very brief answer. -2.79. In the year 2002, what is the difference between the Expenditure(as % of GDP) in Romania and Expenditure(as % of GDP) in Uganda?
Your answer should be compact. -3.92. In the year 2003, what is the difference between the Expenditure(as % of GDP) of Bahamas and Expenditure(as % of GDP) of Botswana?
Make the answer very short. 1.31. In the year 2003, what is the difference between the Expenditure(as % of GDP) of Bahamas and Expenditure(as % of GDP) of Romania?
Your response must be concise. 0.28. In the year 2003, what is the difference between the Expenditure(as % of GDP) of Bahamas and Expenditure(as % of GDP) of Uganda?
Make the answer very short. -2.63. In the year 2003, what is the difference between the Expenditure(as % of GDP) of Botswana and Expenditure(as % of GDP) of Romania?
Make the answer very short. -1.03. In the year 2003, what is the difference between the Expenditure(as % of GDP) in Botswana and Expenditure(as % of GDP) in Uganda?
Provide a short and direct response. -3.94. In the year 2003, what is the difference between the Expenditure(as % of GDP) in Romania and Expenditure(as % of GDP) in Uganda?
Make the answer very short. -2.91. In the year 2004, what is the difference between the Expenditure(as % of GDP) in Bahamas and Expenditure(as % of GDP) in Botswana?
Give a very brief answer. 1.08. In the year 2004, what is the difference between the Expenditure(as % of GDP) in Bahamas and Expenditure(as % of GDP) in Romania?
Ensure brevity in your answer.  0.59. In the year 2004, what is the difference between the Expenditure(as % of GDP) in Bahamas and Expenditure(as % of GDP) in Uganda?
Your answer should be compact. -3.71. In the year 2004, what is the difference between the Expenditure(as % of GDP) in Botswana and Expenditure(as % of GDP) in Romania?
Offer a terse response. -0.49. In the year 2004, what is the difference between the Expenditure(as % of GDP) in Botswana and Expenditure(as % of GDP) in Uganda?
Provide a short and direct response. -4.79. In the year 2004, what is the difference between the Expenditure(as % of GDP) in Romania and Expenditure(as % of GDP) in Uganda?
Your answer should be very brief. -4.3. In the year 2005, what is the difference between the Expenditure(as % of GDP) in Bahamas and Expenditure(as % of GDP) in Botswana?
Provide a short and direct response. 0.33. In the year 2005, what is the difference between the Expenditure(as % of GDP) in Bahamas and Expenditure(as % of GDP) in Romania?
Offer a terse response. 0.48. In the year 2005, what is the difference between the Expenditure(as % of GDP) in Bahamas and Expenditure(as % of GDP) in Uganda?
Your answer should be very brief. -4.29. In the year 2005, what is the difference between the Expenditure(as % of GDP) in Botswana and Expenditure(as % of GDP) in Romania?
Keep it short and to the point. 0.15. In the year 2005, what is the difference between the Expenditure(as % of GDP) in Botswana and Expenditure(as % of GDP) in Uganda?
Your answer should be very brief. -4.62. In the year 2005, what is the difference between the Expenditure(as % of GDP) of Romania and Expenditure(as % of GDP) of Uganda?
Give a very brief answer. -4.77. In the year 2006, what is the difference between the Expenditure(as % of GDP) of Bahamas and Expenditure(as % of GDP) of Botswana?
Keep it short and to the point. 2. In the year 2006, what is the difference between the Expenditure(as % of GDP) in Bahamas and Expenditure(as % of GDP) in Romania?
Provide a succinct answer. 1.85. In the year 2006, what is the difference between the Expenditure(as % of GDP) of Bahamas and Expenditure(as % of GDP) of Uganda?
Offer a very short reply. -1.05. In the year 2006, what is the difference between the Expenditure(as % of GDP) in Botswana and Expenditure(as % of GDP) in Romania?
Your response must be concise. -0.16. In the year 2006, what is the difference between the Expenditure(as % of GDP) of Botswana and Expenditure(as % of GDP) of Uganda?
Provide a short and direct response. -3.05. In the year 2006, what is the difference between the Expenditure(as % of GDP) in Romania and Expenditure(as % of GDP) in Uganda?
Your answer should be compact. -2.89. In the year 2007, what is the difference between the Expenditure(as % of GDP) of Bahamas and Expenditure(as % of GDP) of Botswana?
Ensure brevity in your answer.  2.36. In the year 2007, what is the difference between the Expenditure(as % of GDP) in Bahamas and Expenditure(as % of GDP) in Romania?
Provide a short and direct response. 1.85. In the year 2007, what is the difference between the Expenditure(as % of GDP) in Bahamas and Expenditure(as % of GDP) in Uganda?
Offer a very short reply. -2.39. In the year 2007, what is the difference between the Expenditure(as % of GDP) of Botswana and Expenditure(as % of GDP) of Romania?
Your answer should be compact. -0.52. In the year 2007, what is the difference between the Expenditure(as % of GDP) in Botswana and Expenditure(as % of GDP) in Uganda?
Provide a succinct answer. -4.75. In the year 2007, what is the difference between the Expenditure(as % of GDP) in Romania and Expenditure(as % of GDP) in Uganda?
Keep it short and to the point. -4.23. In the year 2008, what is the difference between the Expenditure(as % of GDP) in Bahamas and Expenditure(as % of GDP) in Botswana?
Provide a succinct answer. 1.96. In the year 2008, what is the difference between the Expenditure(as % of GDP) in Bahamas and Expenditure(as % of GDP) in Romania?
Make the answer very short. 1.87. In the year 2008, what is the difference between the Expenditure(as % of GDP) of Bahamas and Expenditure(as % of GDP) of Uganda?
Offer a very short reply. -2.67. In the year 2008, what is the difference between the Expenditure(as % of GDP) in Botswana and Expenditure(as % of GDP) in Romania?
Give a very brief answer. -0.09. In the year 2008, what is the difference between the Expenditure(as % of GDP) in Botswana and Expenditure(as % of GDP) in Uganda?
Provide a short and direct response. -4.63. In the year 2008, what is the difference between the Expenditure(as % of GDP) in Romania and Expenditure(as % of GDP) in Uganda?
Provide a short and direct response. -4.54. What is the ratio of the Expenditure(as % of GDP) in Bahamas in 2001 to that in 2002?
Provide a succinct answer. 0.98. What is the ratio of the Expenditure(as % of GDP) in Botswana in 2001 to that in 2002?
Offer a very short reply. 0.9. What is the ratio of the Expenditure(as % of GDP) in Romania in 2001 to that in 2002?
Give a very brief answer. 0.95. What is the ratio of the Expenditure(as % of GDP) in Uganda in 2001 to that in 2002?
Give a very brief answer. 0.93. What is the ratio of the Expenditure(as % of GDP) of Bahamas in 2001 to that in 2003?
Give a very brief answer. 0.92. What is the ratio of the Expenditure(as % of GDP) in Botswana in 2001 to that in 2003?
Make the answer very short. 1.2. What is the ratio of the Expenditure(as % of GDP) of Romania in 2001 to that in 2003?
Keep it short and to the point. 0.82. What is the ratio of the Expenditure(as % of GDP) of Uganda in 2001 to that in 2003?
Make the answer very short. 0.96. What is the ratio of the Expenditure(as % of GDP) of Bahamas in 2001 to that in 2004?
Keep it short and to the point. 0.85. What is the ratio of the Expenditure(as % of GDP) of Botswana in 2001 to that in 2004?
Offer a terse response. 1.05. What is the ratio of the Expenditure(as % of GDP) in Romania in 2001 to that in 2004?
Offer a very short reply. 0.8. What is the ratio of the Expenditure(as % of GDP) of Uganda in 2001 to that in 2004?
Your response must be concise. 0.82. What is the ratio of the Expenditure(as % of GDP) in Bahamas in 2001 to that in 2005?
Offer a terse response. 0.86. What is the ratio of the Expenditure(as % of GDP) of Romania in 2001 to that in 2005?
Provide a short and direct response. 0.8. What is the ratio of the Expenditure(as % of GDP) in Uganda in 2001 to that in 2005?
Offer a terse response. 0.78. What is the ratio of the Expenditure(as % of GDP) of Bahamas in 2001 to that in 2006?
Provide a short and direct response. 0.74. What is the ratio of the Expenditure(as % of GDP) in Botswana in 2001 to that in 2006?
Your response must be concise. 1.05. What is the ratio of the Expenditure(as % of GDP) in Romania in 2001 to that in 2006?
Your answer should be very brief. 0.86. What is the ratio of the Expenditure(as % of GDP) in Bahamas in 2001 to that in 2007?
Provide a short and direct response. 0.73. What is the ratio of the Expenditure(as % of GDP) in Botswana in 2001 to that in 2007?
Ensure brevity in your answer.  1.1. What is the ratio of the Expenditure(as % of GDP) in Romania in 2001 to that in 2007?
Make the answer very short. 0.84. What is the ratio of the Expenditure(as % of GDP) in Uganda in 2001 to that in 2007?
Offer a very short reply. 0.84. What is the ratio of the Expenditure(as % of GDP) of Bahamas in 2001 to that in 2008?
Your answer should be very brief. 0.7. What is the ratio of the Expenditure(as % of GDP) of Botswana in 2001 to that in 2008?
Keep it short and to the point. 0.97. What is the ratio of the Expenditure(as % of GDP) of Romania in 2001 to that in 2008?
Your answer should be very brief. 0.8. What is the ratio of the Expenditure(as % of GDP) of Uganda in 2001 to that in 2008?
Your response must be concise. 0.8. What is the ratio of the Expenditure(as % of GDP) in Bahamas in 2002 to that in 2003?
Your response must be concise. 0.94. What is the ratio of the Expenditure(as % of GDP) in Botswana in 2002 to that in 2003?
Provide a short and direct response. 1.33. What is the ratio of the Expenditure(as % of GDP) in Romania in 2002 to that in 2003?
Provide a succinct answer. 0.86. What is the ratio of the Expenditure(as % of GDP) of Uganda in 2002 to that in 2003?
Give a very brief answer. 1.03. What is the ratio of the Expenditure(as % of GDP) of Bahamas in 2002 to that in 2004?
Provide a succinct answer. 0.87. What is the ratio of the Expenditure(as % of GDP) of Botswana in 2002 to that in 2004?
Give a very brief answer. 1.16. What is the ratio of the Expenditure(as % of GDP) in Romania in 2002 to that in 2004?
Offer a very short reply. 0.84. What is the ratio of the Expenditure(as % of GDP) of Bahamas in 2002 to that in 2005?
Provide a short and direct response. 0.88. What is the ratio of the Expenditure(as % of GDP) in Botswana in 2002 to that in 2005?
Your answer should be compact. 1.02. What is the ratio of the Expenditure(as % of GDP) of Romania in 2002 to that in 2005?
Ensure brevity in your answer.  0.84. What is the ratio of the Expenditure(as % of GDP) in Uganda in 2002 to that in 2005?
Offer a very short reply. 0.83. What is the ratio of the Expenditure(as % of GDP) of Bahamas in 2002 to that in 2006?
Make the answer very short. 0.76. What is the ratio of the Expenditure(as % of GDP) in Botswana in 2002 to that in 2006?
Ensure brevity in your answer.  1.16. What is the ratio of the Expenditure(as % of GDP) of Romania in 2002 to that in 2006?
Keep it short and to the point. 0.9. What is the ratio of the Expenditure(as % of GDP) in Uganda in 2002 to that in 2006?
Give a very brief answer. 1.07. What is the ratio of the Expenditure(as % of GDP) in Bahamas in 2002 to that in 2007?
Your answer should be compact. 0.74. What is the ratio of the Expenditure(as % of GDP) in Botswana in 2002 to that in 2007?
Your answer should be compact. 1.21. What is the ratio of the Expenditure(as % of GDP) in Romania in 2002 to that in 2007?
Offer a very short reply. 0.88. What is the ratio of the Expenditure(as % of GDP) in Uganda in 2002 to that in 2007?
Provide a short and direct response. 0.9. What is the ratio of the Expenditure(as % of GDP) in Bahamas in 2002 to that in 2008?
Give a very brief answer. 0.72. What is the ratio of the Expenditure(as % of GDP) in Botswana in 2002 to that in 2008?
Offer a terse response. 1.07. What is the ratio of the Expenditure(as % of GDP) of Romania in 2002 to that in 2008?
Your answer should be very brief. 0.84. What is the ratio of the Expenditure(as % of GDP) of Uganda in 2002 to that in 2008?
Your response must be concise. 0.85. What is the ratio of the Expenditure(as % of GDP) in Bahamas in 2003 to that in 2004?
Your answer should be very brief. 0.93. What is the ratio of the Expenditure(as % of GDP) in Botswana in 2003 to that in 2004?
Make the answer very short. 0.87. What is the ratio of the Expenditure(as % of GDP) of Romania in 2003 to that in 2004?
Provide a succinct answer. 0.98. What is the ratio of the Expenditure(as % of GDP) in Uganda in 2003 to that in 2004?
Give a very brief answer. 0.85. What is the ratio of the Expenditure(as % of GDP) in Bahamas in 2003 to that in 2005?
Your answer should be compact. 0.94. What is the ratio of the Expenditure(as % of GDP) in Botswana in 2003 to that in 2005?
Make the answer very short. 0.77. What is the ratio of the Expenditure(as % of GDP) of Romania in 2003 to that in 2005?
Make the answer very short. 0.97. What is the ratio of the Expenditure(as % of GDP) of Uganda in 2003 to that in 2005?
Keep it short and to the point. 0.81. What is the ratio of the Expenditure(as % of GDP) in Bahamas in 2003 to that in 2006?
Ensure brevity in your answer.  0.81. What is the ratio of the Expenditure(as % of GDP) of Botswana in 2003 to that in 2006?
Your answer should be very brief. 0.87. What is the ratio of the Expenditure(as % of GDP) of Romania in 2003 to that in 2006?
Ensure brevity in your answer.  1.05. What is the ratio of the Expenditure(as % of GDP) of Uganda in 2003 to that in 2006?
Provide a succinct answer. 1.03. What is the ratio of the Expenditure(as % of GDP) in Bahamas in 2003 to that in 2007?
Make the answer very short. 0.79. What is the ratio of the Expenditure(as % of GDP) in Botswana in 2003 to that in 2007?
Provide a short and direct response. 0.91. What is the ratio of the Expenditure(as % of GDP) in Romania in 2003 to that in 2007?
Your answer should be very brief. 1.02. What is the ratio of the Expenditure(as % of GDP) of Uganda in 2003 to that in 2007?
Your answer should be compact. 0.87. What is the ratio of the Expenditure(as % of GDP) in Bahamas in 2003 to that in 2008?
Keep it short and to the point. 0.77. What is the ratio of the Expenditure(as % of GDP) of Botswana in 2003 to that in 2008?
Ensure brevity in your answer.  0.81. What is the ratio of the Expenditure(as % of GDP) of Romania in 2003 to that in 2008?
Your answer should be very brief. 0.98. What is the ratio of the Expenditure(as % of GDP) of Uganda in 2003 to that in 2008?
Give a very brief answer. 0.83. What is the ratio of the Expenditure(as % of GDP) in Bahamas in 2004 to that in 2005?
Keep it short and to the point. 1.01. What is the ratio of the Expenditure(as % of GDP) of Botswana in 2004 to that in 2005?
Give a very brief answer. 0.88. What is the ratio of the Expenditure(as % of GDP) of Uganda in 2004 to that in 2005?
Provide a short and direct response. 0.95. What is the ratio of the Expenditure(as % of GDP) of Bahamas in 2004 to that in 2006?
Give a very brief answer. 0.87. What is the ratio of the Expenditure(as % of GDP) of Romania in 2004 to that in 2006?
Ensure brevity in your answer.  1.07. What is the ratio of the Expenditure(as % of GDP) of Uganda in 2004 to that in 2006?
Keep it short and to the point. 1.22. What is the ratio of the Expenditure(as % of GDP) in Bahamas in 2004 to that in 2007?
Make the answer very short. 0.85. What is the ratio of the Expenditure(as % of GDP) in Botswana in 2004 to that in 2007?
Your answer should be very brief. 1.05. What is the ratio of the Expenditure(as % of GDP) in Romania in 2004 to that in 2007?
Make the answer very short. 1.04. What is the ratio of the Expenditure(as % of GDP) of Uganda in 2004 to that in 2007?
Give a very brief answer. 1.03. What is the ratio of the Expenditure(as % of GDP) of Bahamas in 2004 to that in 2008?
Give a very brief answer. 0.82. What is the ratio of the Expenditure(as % of GDP) in Botswana in 2004 to that in 2008?
Your answer should be compact. 0.92. What is the ratio of the Expenditure(as % of GDP) of Romania in 2004 to that in 2008?
Give a very brief answer. 1. What is the ratio of the Expenditure(as % of GDP) of Uganda in 2004 to that in 2008?
Provide a short and direct response. 0.98. What is the ratio of the Expenditure(as % of GDP) of Bahamas in 2005 to that in 2006?
Give a very brief answer. 0.86. What is the ratio of the Expenditure(as % of GDP) of Botswana in 2005 to that in 2006?
Your answer should be very brief. 1.14. What is the ratio of the Expenditure(as % of GDP) of Romania in 2005 to that in 2006?
Ensure brevity in your answer.  1.08. What is the ratio of the Expenditure(as % of GDP) of Uganda in 2005 to that in 2006?
Provide a succinct answer. 1.28. What is the ratio of the Expenditure(as % of GDP) in Bahamas in 2005 to that in 2007?
Your answer should be compact. 0.84. What is the ratio of the Expenditure(as % of GDP) of Botswana in 2005 to that in 2007?
Your answer should be compact. 1.19. What is the ratio of the Expenditure(as % of GDP) of Romania in 2005 to that in 2007?
Your answer should be very brief. 1.05. What is the ratio of the Expenditure(as % of GDP) in Uganda in 2005 to that in 2007?
Keep it short and to the point. 1.08. What is the ratio of the Expenditure(as % of GDP) of Bahamas in 2005 to that in 2008?
Keep it short and to the point. 0.82. What is the ratio of the Expenditure(as % of GDP) in Botswana in 2005 to that in 2008?
Your answer should be very brief. 1.05. What is the ratio of the Expenditure(as % of GDP) in Romania in 2005 to that in 2008?
Keep it short and to the point. 1.01. What is the ratio of the Expenditure(as % of GDP) in Uganda in 2005 to that in 2008?
Provide a succinct answer. 1.03. What is the ratio of the Expenditure(as % of GDP) of Bahamas in 2006 to that in 2007?
Your answer should be very brief. 0.98. What is the ratio of the Expenditure(as % of GDP) of Botswana in 2006 to that in 2007?
Offer a very short reply. 1.05. What is the ratio of the Expenditure(as % of GDP) in Romania in 2006 to that in 2007?
Your answer should be very brief. 0.97. What is the ratio of the Expenditure(as % of GDP) in Uganda in 2006 to that in 2007?
Ensure brevity in your answer.  0.84. What is the ratio of the Expenditure(as % of GDP) of Bahamas in 2006 to that in 2008?
Your response must be concise. 0.95. What is the ratio of the Expenditure(as % of GDP) in Botswana in 2006 to that in 2008?
Your response must be concise. 0.92. What is the ratio of the Expenditure(as % of GDP) in Romania in 2006 to that in 2008?
Keep it short and to the point. 0.94. What is the ratio of the Expenditure(as % of GDP) in Uganda in 2006 to that in 2008?
Keep it short and to the point. 0.8. What is the ratio of the Expenditure(as % of GDP) in Bahamas in 2007 to that in 2008?
Keep it short and to the point. 0.97. What is the ratio of the Expenditure(as % of GDP) of Botswana in 2007 to that in 2008?
Your answer should be compact. 0.88. What is the ratio of the Expenditure(as % of GDP) in Romania in 2007 to that in 2008?
Offer a terse response. 0.96. What is the ratio of the Expenditure(as % of GDP) of Uganda in 2007 to that in 2008?
Ensure brevity in your answer.  0.95. What is the difference between the highest and the second highest Expenditure(as % of GDP) of Bahamas?
Ensure brevity in your answer.  0.23. What is the difference between the highest and the second highest Expenditure(as % of GDP) of Botswana?
Offer a terse response. 0.1. What is the difference between the highest and the second highest Expenditure(as % of GDP) in Romania?
Ensure brevity in your answer.  0.04. What is the difference between the highest and the second highest Expenditure(as % of GDP) in Uganda?
Your answer should be compact. 0.27. What is the difference between the highest and the lowest Expenditure(as % of GDP) in Bahamas?
Provide a succinct answer. 2.16. What is the difference between the highest and the lowest Expenditure(as % of GDP) in Botswana?
Provide a short and direct response. 1.42. What is the difference between the highest and the lowest Expenditure(as % of GDP) in Romania?
Ensure brevity in your answer.  1.1. What is the difference between the highest and the lowest Expenditure(as % of GDP) of Uganda?
Keep it short and to the point. 2.3. 